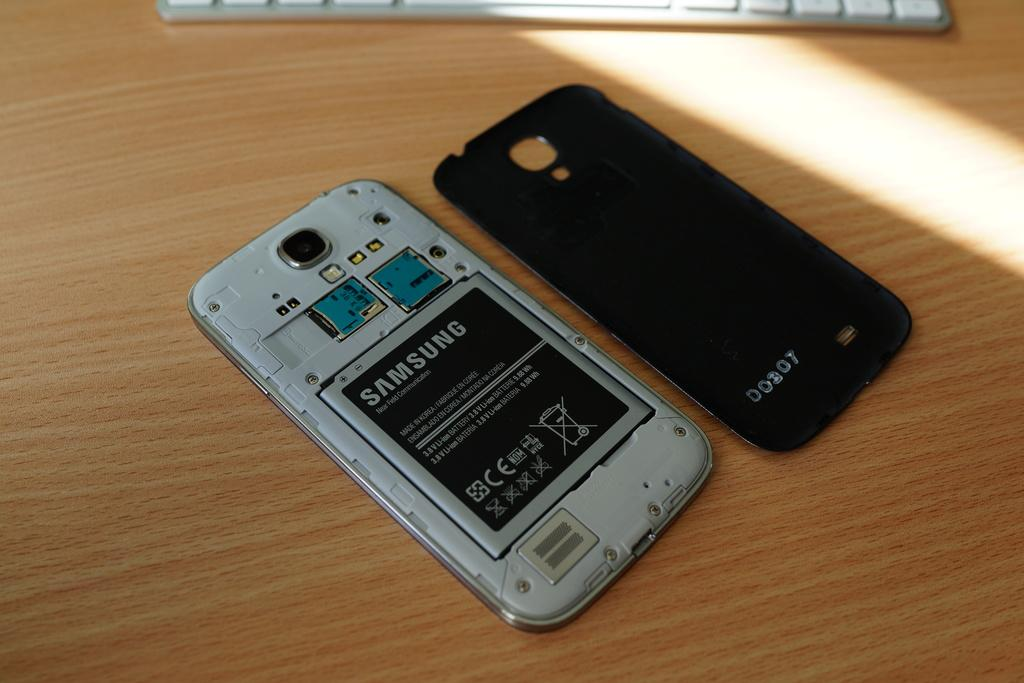<image>
Render a clear and concise summary of the photo. A phone is opened up, facing down, with a Samsung brand battery in it. 